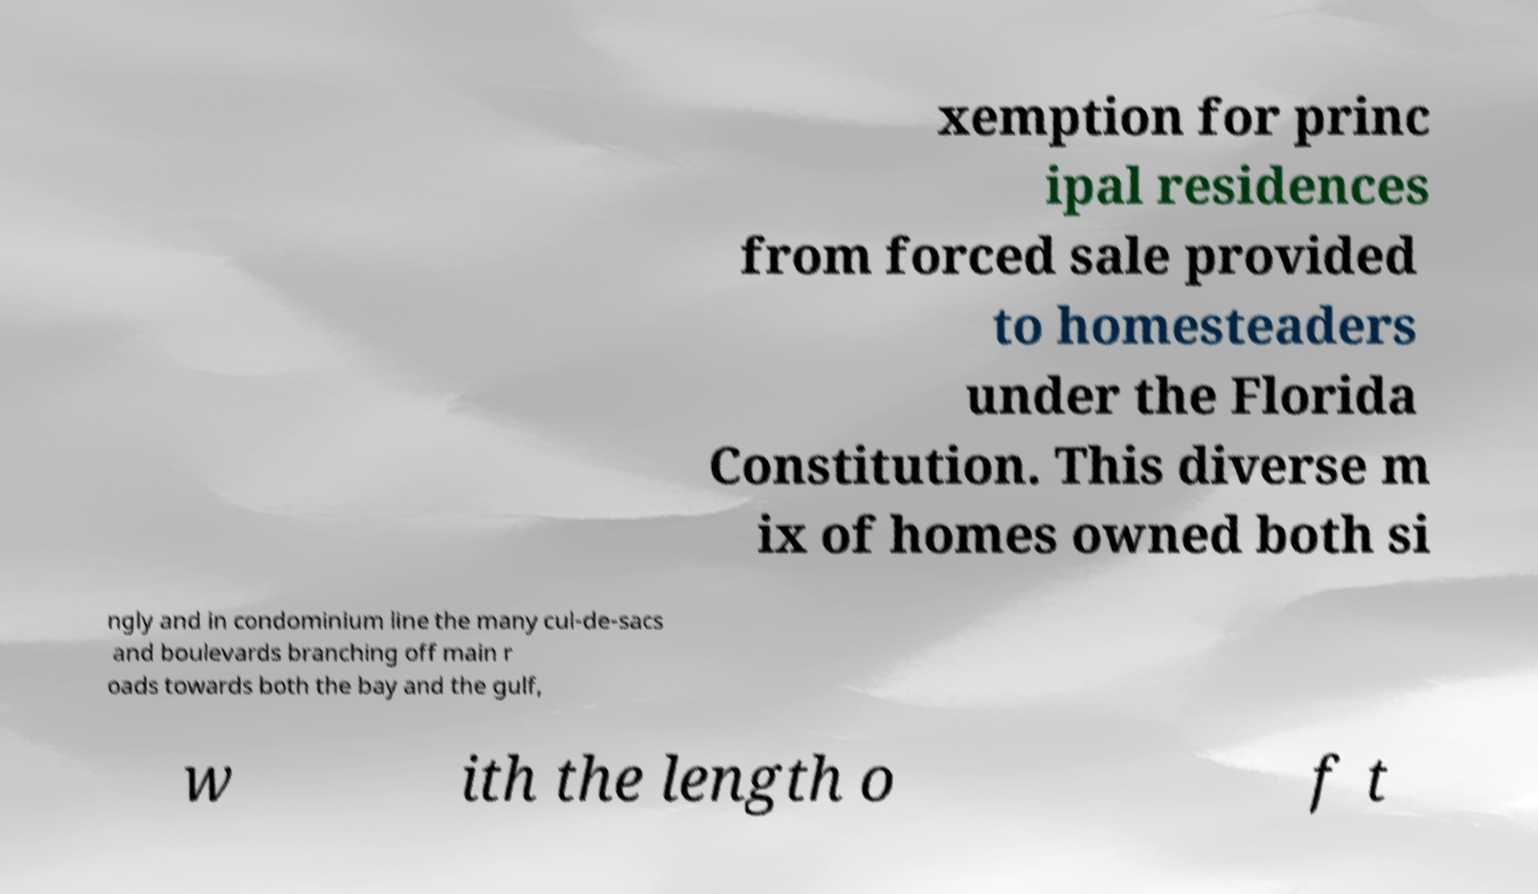There's text embedded in this image that I need extracted. Can you transcribe it verbatim? xemption for princ ipal residences from forced sale provided to homesteaders under the Florida Constitution. This diverse m ix of homes owned both si ngly and in condominium line the many cul-de-sacs and boulevards branching off main r oads towards both the bay and the gulf, w ith the length o f t 